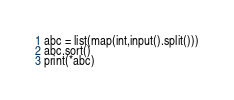Convert code to text. <code><loc_0><loc_0><loc_500><loc_500><_Python_>abc = list(map(int,input().split()))
abc.sort()
print(*abc)
</code> 